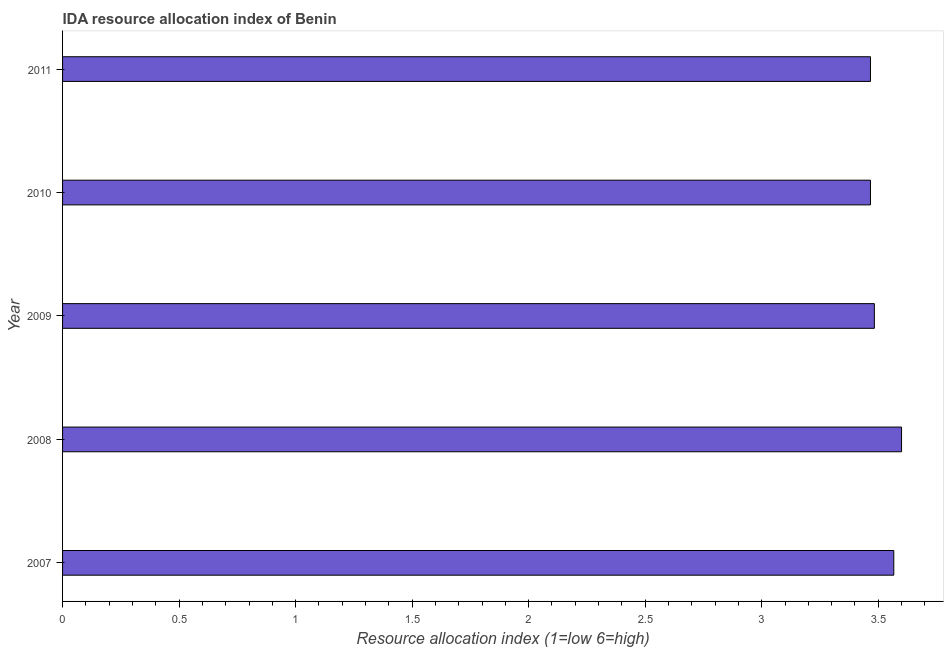Does the graph contain grids?
Make the answer very short. No. What is the title of the graph?
Offer a terse response. IDA resource allocation index of Benin. What is the label or title of the X-axis?
Ensure brevity in your answer.  Resource allocation index (1=low 6=high). What is the label or title of the Y-axis?
Offer a terse response. Year. What is the ida resource allocation index in 2009?
Ensure brevity in your answer.  3.48. Across all years, what is the minimum ida resource allocation index?
Keep it short and to the point. 3.47. In which year was the ida resource allocation index maximum?
Your answer should be very brief. 2008. In which year was the ida resource allocation index minimum?
Your answer should be very brief. 2010. What is the sum of the ida resource allocation index?
Your answer should be very brief. 17.58. What is the average ida resource allocation index per year?
Offer a terse response. 3.52. What is the median ida resource allocation index?
Give a very brief answer. 3.48. In how many years, is the ida resource allocation index greater than 0.1 ?
Give a very brief answer. 5. Do a majority of the years between 2009 and 2011 (inclusive) have ida resource allocation index greater than 1.2 ?
Your answer should be compact. Yes. What is the ratio of the ida resource allocation index in 2008 to that in 2011?
Provide a succinct answer. 1.04. Is the ida resource allocation index in 2007 less than that in 2010?
Ensure brevity in your answer.  No. What is the difference between the highest and the second highest ida resource allocation index?
Provide a succinct answer. 0.03. What is the difference between the highest and the lowest ida resource allocation index?
Provide a succinct answer. 0.13. In how many years, is the ida resource allocation index greater than the average ida resource allocation index taken over all years?
Offer a very short reply. 2. What is the difference between two consecutive major ticks on the X-axis?
Ensure brevity in your answer.  0.5. What is the Resource allocation index (1=low 6=high) of 2007?
Keep it short and to the point. 3.57. What is the Resource allocation index (1=low 6=high) of 2009?
Provide a short and direct response. 3.48. What is the Resource allocation index (1=low 6=high) in 2010?
Provide a short and direct response. 3.47. What is the Resource allocation index (1=low 6=high) in 2011?
Your answer should be very brief. 3.47. What is the difference between the Resource allocation index (1=low 6=high) in 2007 and 2008?
Ensure brevity in your answer.  -0.03. What is the difference between the Resource allocation index (1=low 6=high) in 2007 and 2009?
Ensure brevity in your answer.  0.08. What is the difference between the Resource allocation index (1=low 6=high) in 2008 and 2009?
Your answer should be very brief. 0.12. What is the difference between the Resource allocation index (1=low 6=high) in 2008 and 2010?
Keep it short and to the point. 0.13. What is the difference between the Resource allocation index (1=low 6=high) in 2008 and 2011?
Your answer should be compact. 0.13. What is the difference between the Resource allocation index (1=low 6=high) in 2009 and 2010?
Give a very brief answer. 0.02. What is the difference between the Resource allocation index (1=low 6=high) in 2009 and 2011?
Ensure brevity in your answer.  0.02. What is the ratio of the Resource allocation index (1=low 6=high) in 2007 to that in 2008?
Your response must be concise. 0.99. What is the ratio of the Resource allocation index (1=low 6=high) in 2007 to that in 2010?
Make the answer very short. 1.03. What is the ratio of the Resource allocation index (1=low 6=high) in 2008 to that in 2009?
Provide a succinct answer. 1.03. What is the ratio of the Resource allocation index (1=low 6=high) in 2008 to that in 2010?
Offer a very short reply. 1.04. What is the ratio of the Resource allocation index (1=low 6=high) in 2008 to that in 2011?
Keep it short and to the point. 1.04. What is the ratio of the Resource allocation index (1=low 6=high) in 2009 to that in 2010?
Provide a succinct answer. 1. What is the ratio of the Resource allocation index (1=low 6=high) in 2009 to that in 2011?
Your response must be concise. 1. What is the ratio of the Resource allocation index (1=low 6=high) in 2010 to that in 2011?
Your answer should be compact. 1. 